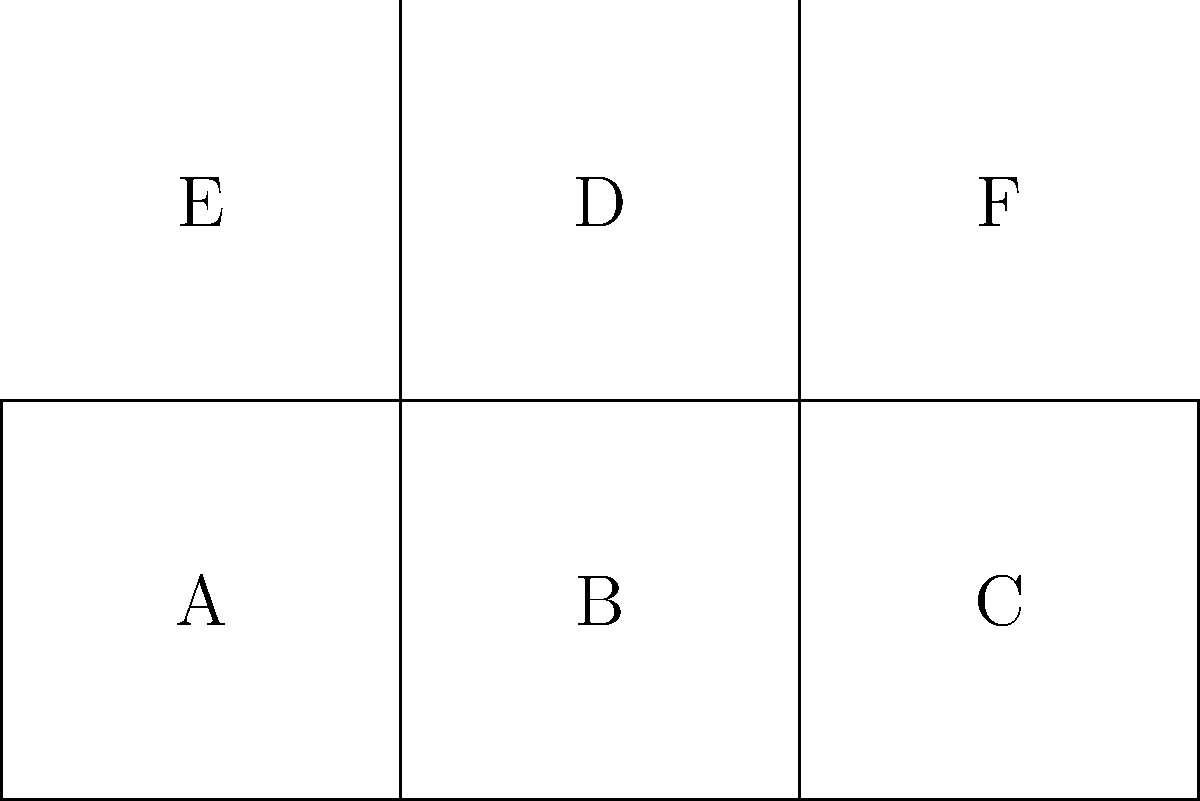As a content writer preparing to describe a new cube-shaped product, you're given the above 2D net representation. When folded into a 3D cube, which face will be opposite to face A? To determine which face will be opposite to face A when the net is folded into a cube, let's follow these steps:

1. Identify the central face: Face B is the central face of the net.

2. Locate face A: Face A is on the left side of face B.

3. Folding process:
   - The left edge of face B will fold up to connect with the right edge of face A.
   - The right edge of face B will fold up to connect with the left edge of face C.
   - The top edge of face B will fold back to connect with the bottom edge of face D.
   - The bottom edge of face B remains in place.

4. Opposite face determination:
   - Face E will fold down to form the top of the cube.
   - Face F will fold down to form the back of the cube.
   - Face C will form the right side of the cube.
   - Face A forms the left side of the cube.
   - Face B forms the bottom of the cube.
   - The only remaining face, D, will fold to form the front of the cube.

5. Conclusion: Since face B forms the bottom of the cube and face D forms the front, the face opposite to A must be C, which forms the right side of the cube.

This spatial reasoning process helps visualize how the 2D net transforms into a 3D cube, allowing us to accurately determine the relative positions of the faces.
Answer: C 